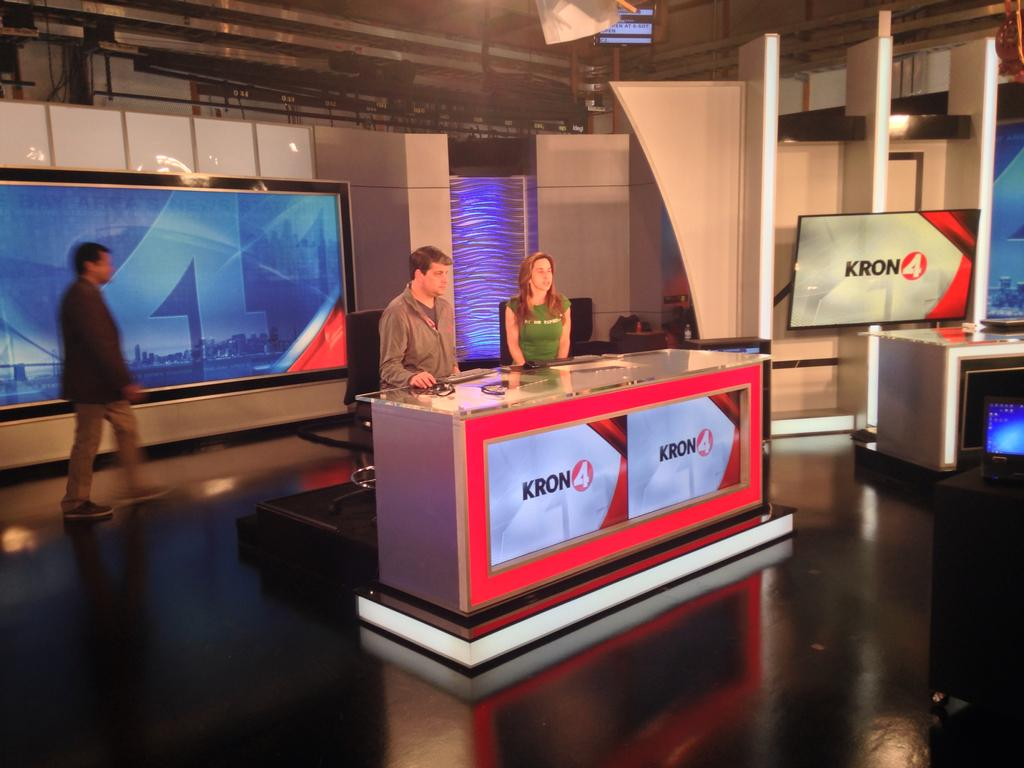<image>
Offer a succinct explanation of the picture presented. Two news reporters sit behind their Kron4 newsdesk as a man walks past behind them. 